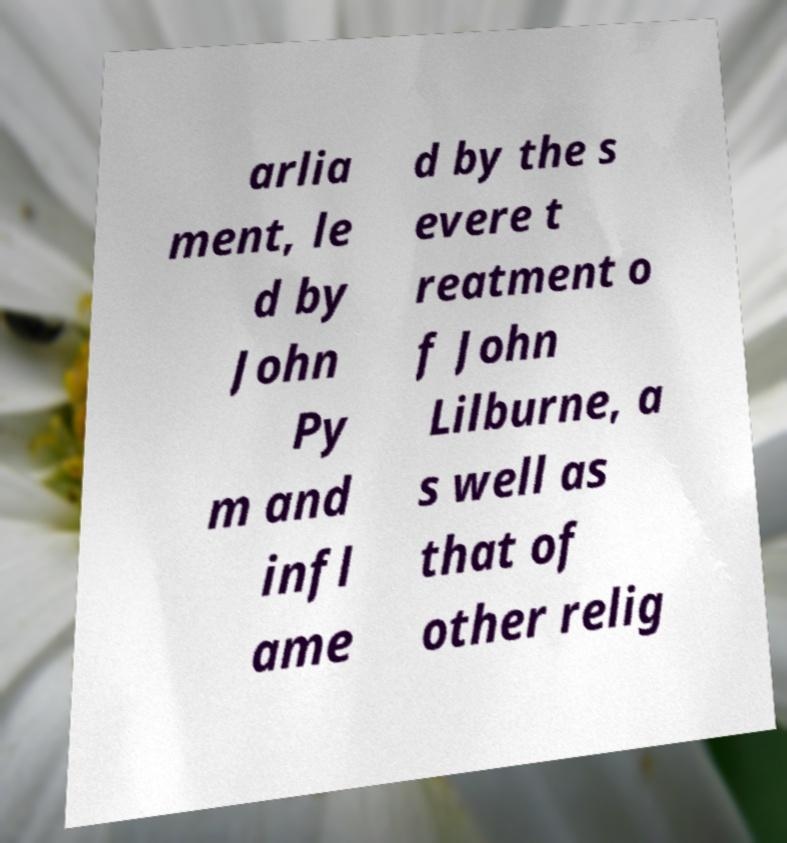Can you read and provide the text displayed in the image?This photo seems to have some interesting text. Can you extract and type it out for me? arlia ment, le d by John Py m and infl ame d by the s evere t reatment o f John Lilburne, a s well as that of other relig 